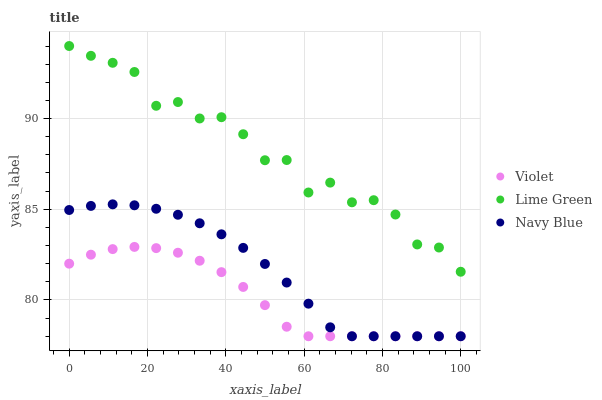Does Violet have the minimum area under the curve?
Answer yes or no. Yes. Does Lime Green have the maximum area under the curve?
Answer yes or no. Yes. Does Lime Green have the minimum area under the curve?
Answer yes or no. No. Does Violet have the maximum area under the curve?
Answer yes or no. No. Is Navy Blue the smoothest?
Answer yes or no. Yes. Is Lime Green the roughest?
Answer yes or no. Yes. Is Violet the smoothest?
Answer yes or no. No. Is Violet the roughest?
Answer yes or no. No. Does Navy Blue have the lowest value?
Answer yes or no. Yes. Does Lime Green have the lowest value?
Answer yes or no. No. Does Lime Green have the highest value?
Answer yes or no. Yes. Does Violet have the highest value?
Answer yes or no. No. Is Violet less than Lime Green?
Answer yes or no. Yes. Is Lime Green greater than Navy Blue?
Answer yes or no. Yes. Does Violet intersect Navy Blue?
Answer yes or no. Yes. Is Violet less than Navy Blue?
Answer yes or no. No. Is Violet greater than Navy Blue?
Answer yes or no. No. Does Violet intersect Lime Green?
Answer yes or no. No. 